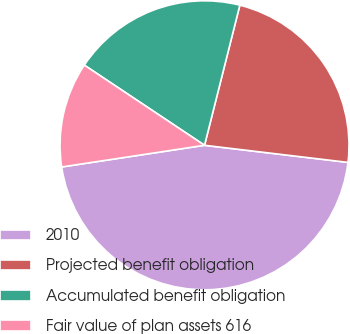Convert chart. <chart><loc_0><loc_0><loc_500><loc_500><pie_chart><fcel>2010<fcel>Projected benefit obligation<fcel>Accumulated benefit obligation<fcel>Fair value of plan assets 616<nl><fcel>45.71%<fcel>22.96%<fcel>19.57%<fcel>11.76%<nl></chart> 